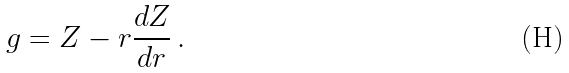Convert formula to latex. <formula><loc_0><loc_0><loc_500><loc_500>g = Z - r \frac { d Z } { d r } \, .</formula> 